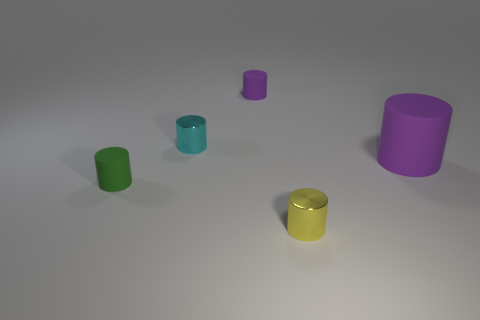Is the shape of the yellow metal thing the same as the cyan object?
Provide a succinct answer. Yes. What number of green objects are the same shape as the big purple thing?
Keep it short and to the point. 1. There is a metal cylinder behind the cylinder that is in front of the small matte thing that is on the left side of the small cyan metallic cylinder; what color is it?
Offer a terse response. Cyan. How many big things are yellow balls or yellow metallic cylinders?
Your response must be concise. 0. Is the number of tiny rubber cylinders in front of the tiny yellow shiny cylinder the same as the number of small blue shiny cubes?
Make the answer very short. Yes. There is a cyan shiny thing; are there any tiny cyan metal objects behind it?
Keep it short and to the point. No. What number of matte objects are either cyan cubes or tiny things?
Keep it short and to the point. 2. What number of cylinders are right of the tiny yellow object?
Give a very brief answer. 1. Are there any things that have the same size as the yellow metal cylinder?
Your answer should be compact. Yes. Is there another rubber thing that has the same color as the big matte thing?
Ensure brevity in your answer.  Yes. 